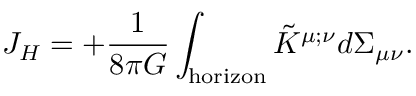Convert formula to latex. <formula><loc_0><loc_0><loc_500><loc_500>J _ { H } = + { \frac { 1 } { 8 \pi G } } \int _ { h o r i z o n } \tilde { K } ^ { \mu ; \nu } d \Sigma _ { \mu \nu } .</formula> 